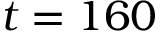Convert formula to latex. <formula><loc_0><loc_0><loc_500><loc_500>t = 1 6 0</formula> 